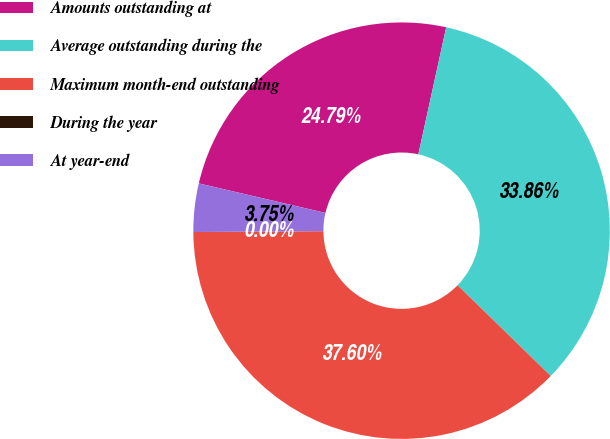<chart> <loc_0><loc_0><loc_500><loc_500><pie_chart><fcel>Amounts outstanding at<fcel>Average outstanding during the<fcel>Maximum month-end outstanding<fcel>During the year<fcel>At year-end<nl><fcel>24.79%<fcel>33.86%<fcel>37.6%<fcel>0.0%<fcel>3.75%<nl></chart> 